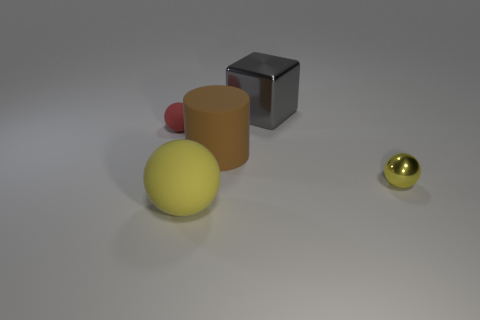Add 4 red rubber balls. How many objects exist? 9 Subtract all cubes. How many objects are left? 4 Subtract all large blue matte cylinders. Subtract all big brown cylinders. How many objects are left? 4 Add 2 tiny yellow metal spheres. How many tiny yellow metal spheres are left? 3 Add 5 tiny matte objects. How many tiny matte objects exist? 6 Subtract 0 red cubes. How many objects are left? 5 